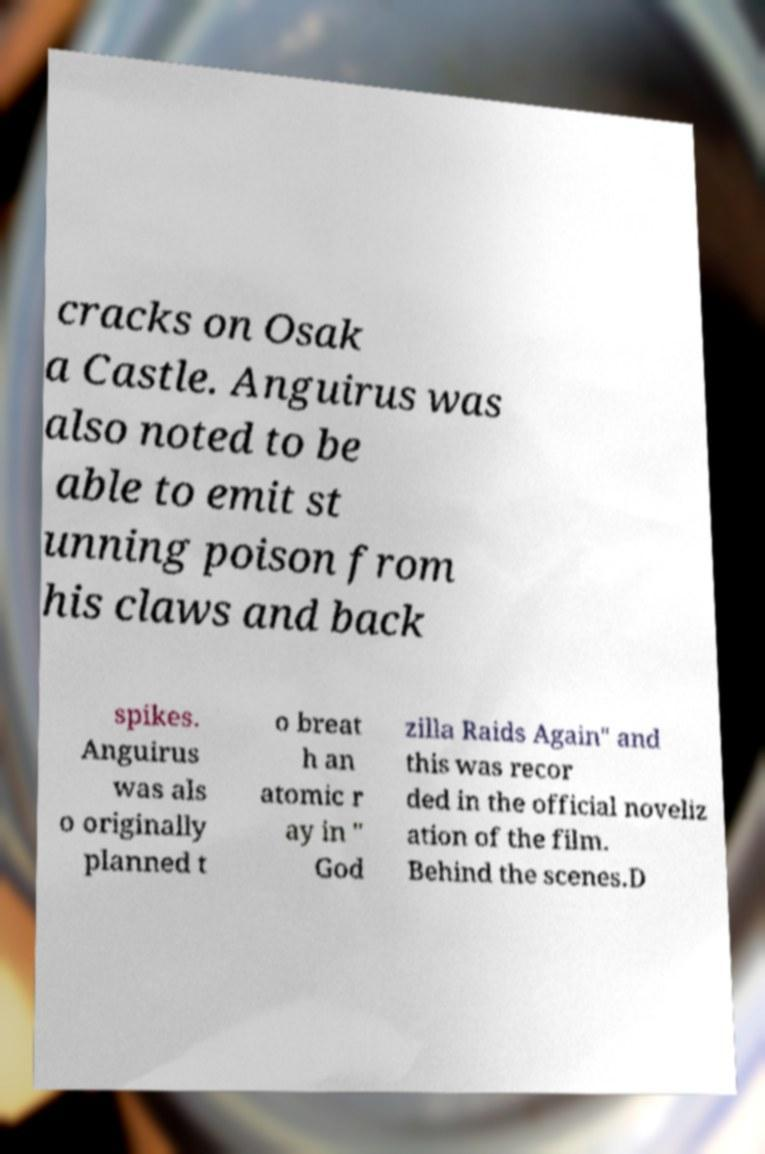Could you extract and type out the text from this image? cracks on Osak a Castle. Anguirus was also noted to be able to emit st unning poison from his claws and back spikes. Anguirus was als o originally planned t o breat h an atomic r ay in " God zilla Raids Again" and this was recor ded in the official noveliz ation of the film. Behind the scenes.D 